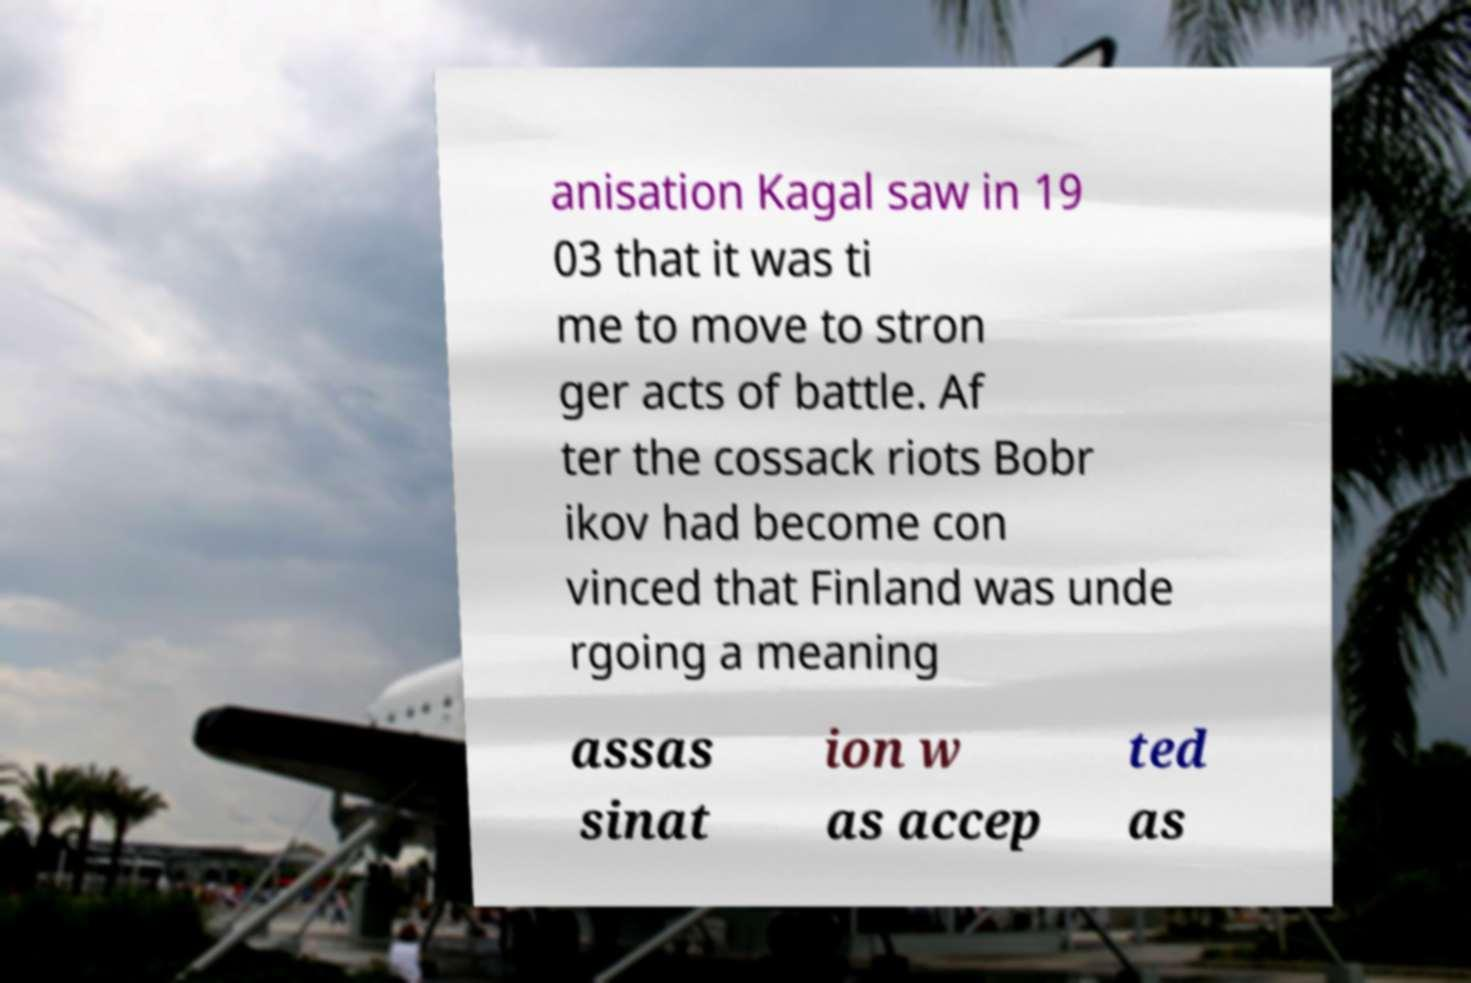There's text embedded in this image that I need extracted. Can you transcribe it verbatim? anisation Kagal saw in 19 03 that it was ti me to move to stron ger acts of battle. Af ter the cossack riots Bobr ikov had become con vinced that Finland was unde rgoing a meaning assas sinat ion w as accep ted as 